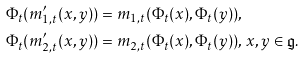Convert formula to latex. <formula><loc_0><loc_0><loc_500><loc_500>& \Phi _ { t } ( m \rq _ { 1 , t } ( x , y ) ) = m _ { 1 , t } ( \Phi _ { t } ( x ) , \Phi _ { t } ( y ) ) , \\ & \Phi _ { t } ( m \rq _ { 2 , t } ( x , y ) ) = m _ { 2 , t } ( \Phi _ { t } ( x ) , \Phi _ { t } ( y ) ) , \, x , y \in \mathfrak { g } .</formula> 